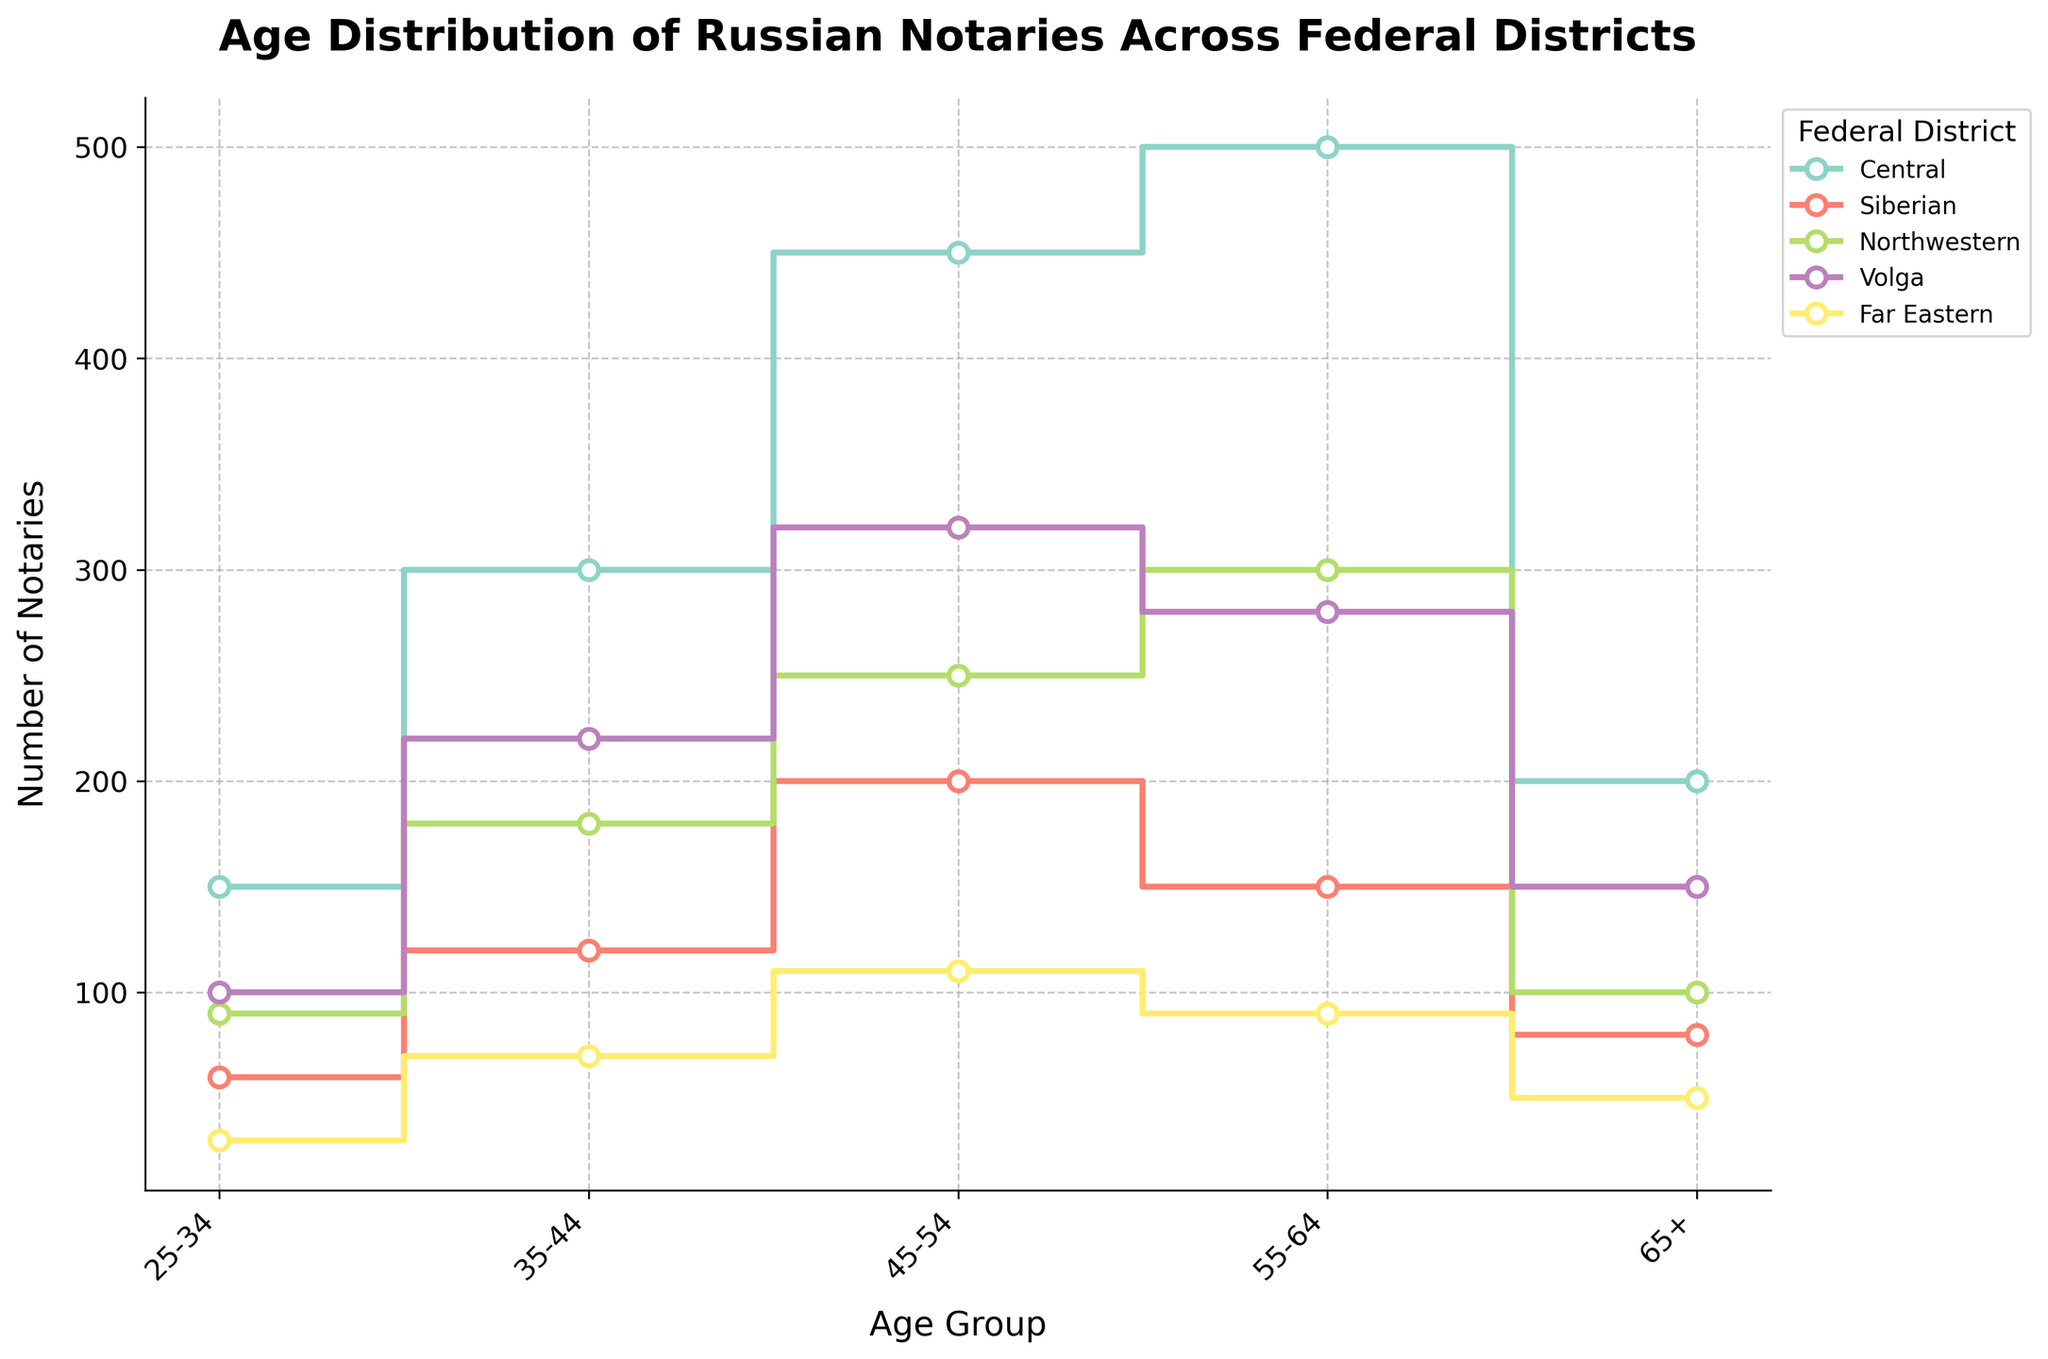What is the title of the figure? The title of the figure is written at the top and generally summarizes the content of the plot, which, in this case, indicates the distribution of notaries by age across different federal districts.
Answer: Age Distribution of Russian Notaries Across Federal Districts Which federal district has the highest number of notaries in the age group 55-64? To determine this, look at the line heights in the 55-64 age group for each federal district. The Central district has the highest line peak within this age group.
Answer: Central How many notaries are in the 35-44 age group in the Far Eastern district? Locate the line corresponding to the Far Eastern district and read the value at the 35-44 age group. This district's data point for this age group is at 70.
Answer: 70 What's the sum of notaries aged 45-54 across all districts? Sum the number of notaries in the 45-54 age group for each district: Central (450) + Siberian (200) + Northwestern (250) + Volga (320) + Far Eastern (110) = 1330.
Answer: 1330 Which age group has the least number of notaries in the Northwestern district? Examine the values along the Northwestern district's line to find the point corresponding to the minimum number of notaries. The 25-34 age group shows the smallest number at 90.
Answer: 25-34 In which age group does the Volga district have more notaries than the Northwestern district? Compare the lines for the Volga and Northwestern districts across age groups. The Volga district surpasses Northwestern in the 35-44 (220 > 180) and 45-54 (320 > 250) age groups.
Answer: 35-44, 45-54 What's the difference between the number of notaries aged 65+ in the Central district and the Siberian district? Subtract the number of notaries in the 65+ age group of the Siberian district from that of the Central district: 200 - 80 = 120.
Answer: 120 Which federal district shows the largest drop-off in the number of notaries from the 55-64 age group to the 65+ age group? Calculate the difference between the two age groups for each district, and identify the maximum drop. Central (500-200=300), Siberian (150-80=70), Northwestern (300-100=200), Volga (280-150=130), Far Eastern (90-50=40). The Central district has the largest drop at 300.
Answer: Central How does the total number of notaries in the 25-34 age group compare across all districts? Summarize the number of notaries for each district in the 25-34 age group: Central (150), Siberian (60), Northwestern (90), Volga (100), and Far Eastern (30). The totals give each district's proportion within this age group.
Answer: Central > Volga > Northwestern > Siberian > Far Eastern What is the average number of notaries in the 55-64 age group across all districts? Sum the number of notaries in the 55-64 age group, then divide by the number of districts: (Central 500 + Siberian 150 + Northwestern 300 + Volga 280 + Far Eastern 90) / 5 = 1320 / 5 = 264.
Answer: 264 